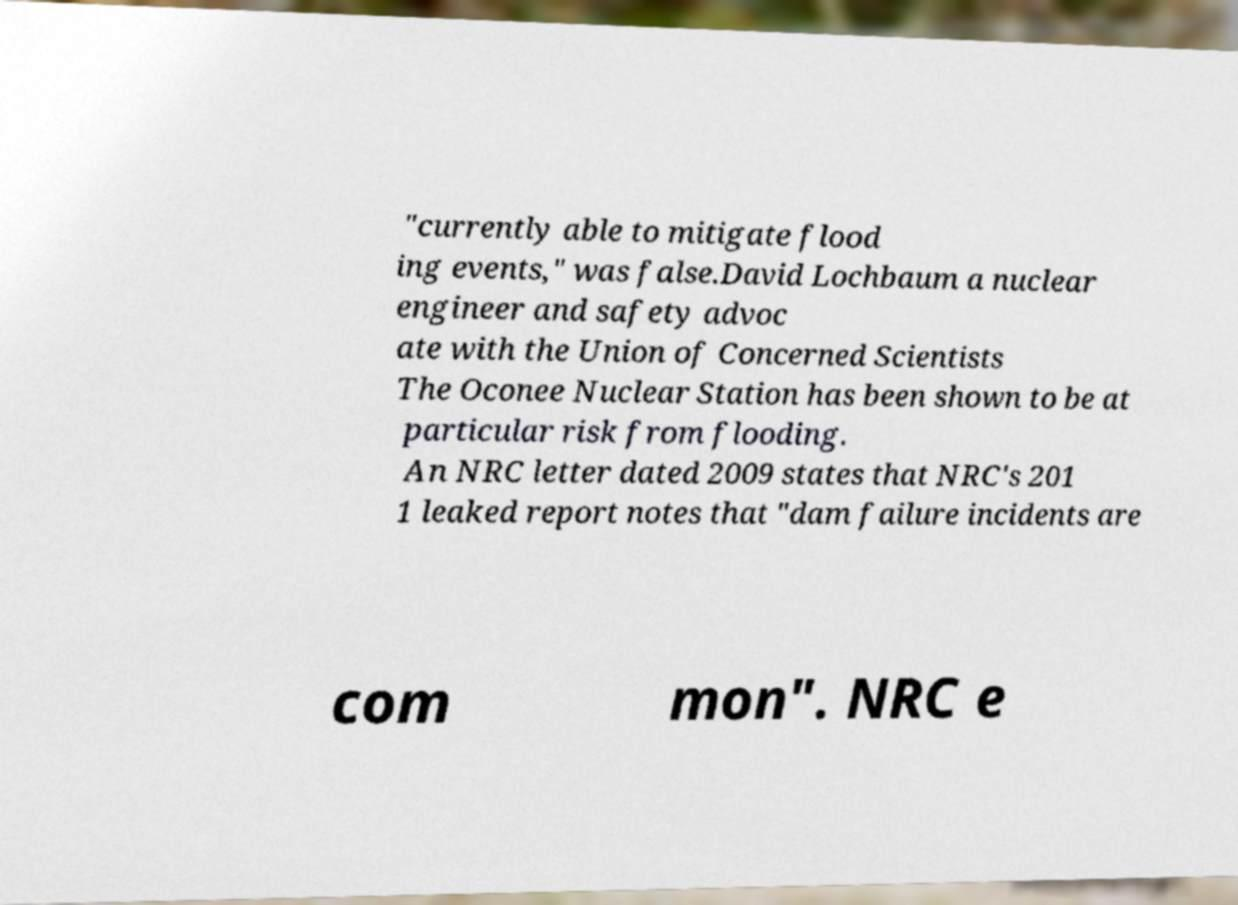Could you extract and type out the text from this image? "currently able to mitigate flood ing events," was false.David Lochbaum a nuclear engineer and safety advoc ate with the Union of Concerned Scientists The Oconee Nuclear Station has been shown to be at particular risk from flooding. An NRC letter dated 2009 states that NRC's 201 1 leaked report notes that "dam failure incidents are com mon". NRC e 